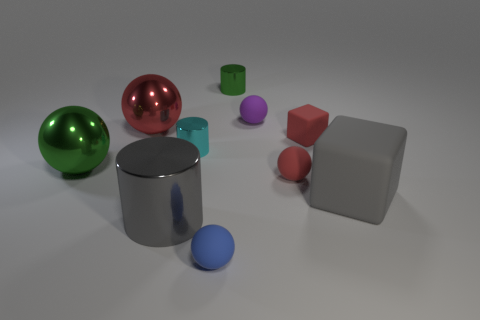Subtract all green cubes. Subtract all green cylinders. How many cubes are left? 2 Subtract all cubes. How many objects are left? 8 Subtract 0 brown cubes. How many objects are left? 10 Subtract all purple matte balls. Subtract all small blue rubber spheres. How many objects are left? 8 Add 3 small blue matte spheres. How many small blue matte spheres are left? 4 Add 1 large blue matte objects. How many large blue matte objects exist? 1 